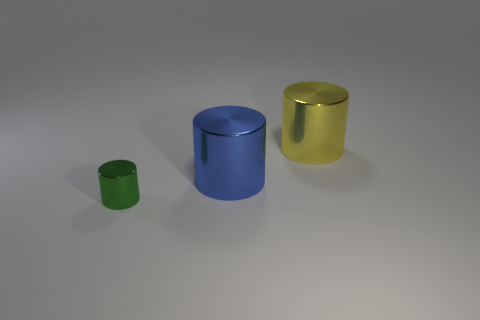Is there any other thing that has the same material as the green thing?
Provide a short and direct response. Yes. Is there another yellow metallic object that has the same shape as the yellow metallic object?
Offer a very short reply. No. What is the color of the big thing that is in front of the big object that is right of the big thing that is to the left of the big yellow metallic cylinder?
Offer a very short reply. Blue. How many matte objects are either big blue objects or blue balls?
Your response must be concise. 0. Is the number of cylinders that are on the left side of the yellow shiny cylinder greater than the number of things behind the tiny green cylinder?
Give a very brief answer. No. How many other objects are there of the same size as the blue metallic cylinder?
Keep it short and to the point. 1. There is a blue shiny cylinder on the left side of the yellow object on the right side of the blue cylinder; how big is it?
Your response must be concise. Large. How many big things are either yellow metallic blocks or cylinders?
Keep it short and to the point. 2. What is the size of the blue object that is on the left side of the cylinder behind the large cylinder in front of the yellow cylinder?
Make the answer very short. Large. Are there any other things that are the same color as the small cylinder?
Keep it short and to the point. No. 